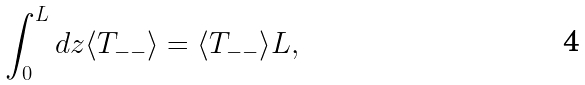<formula> <loc_0><loc_0><loc_500><loc_500>\int _ { 0 } ^ { L } d z \langle T _ { - - } \rangle = \langle T _ { - - } \rangle L ,</formula> 